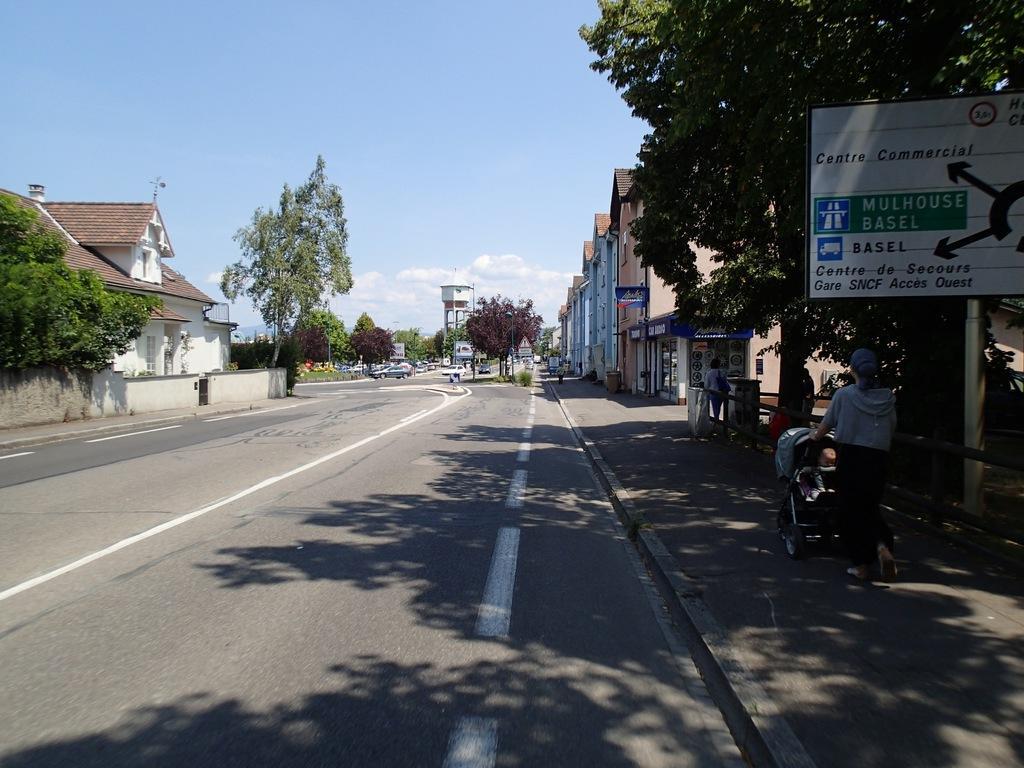Please provide a concise description of this image. In this picture we can see vehicles on the road, beside this road we can see people on a footpath and one woman is holding a stroller, here we can see a fence, name boards, buildings, trees, water tank and some objects and in the background we can see sky with clouds. 